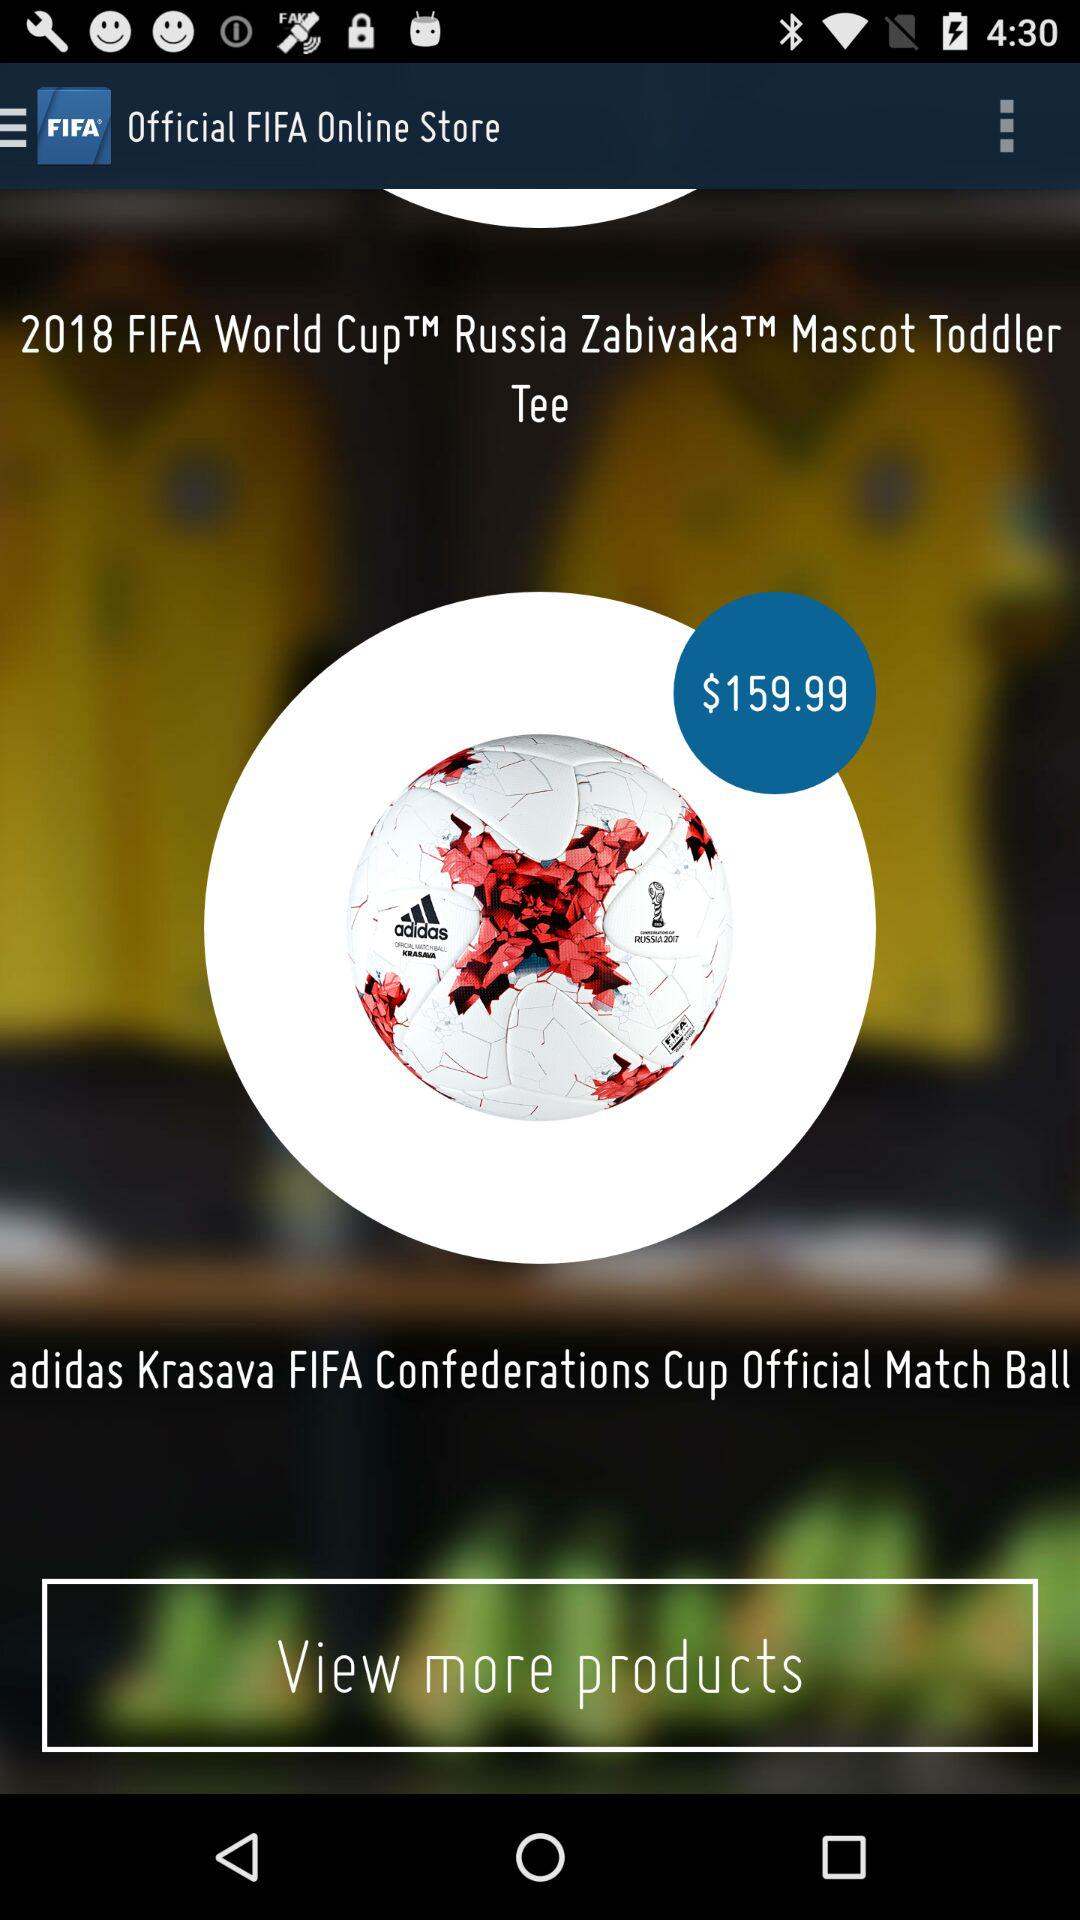The name of the match ball is what? The name of the match ball is adidas Krasava FIFA Confederations Cup Official. 